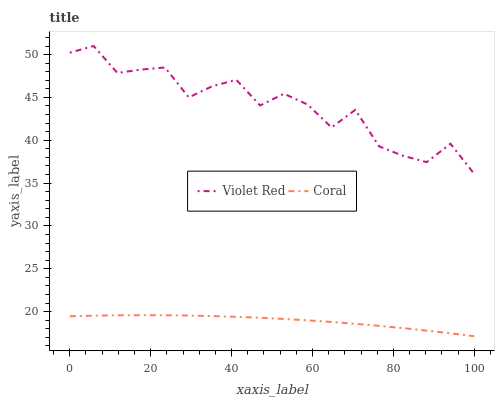Does Coral have the minimum area under the curve?
Answer yes or no. Yes. Does Violet Red have the maximum area under the curve?
Answer yes or no. Yes. Does Coral have the maximum area under the curve?
Answer yes or no. No. Is Coral the smoothest?
Answer yes or no. Yes. Is Violet Red the roughest?
Answer yes or no. Yes. Is Coral the roughest?
Answer yes or no. No. Does Coral have the lowest value?
Answer yes or no. Yes. Does Violet Red have the highest value?
Answer yes or no. Yes. Does Coral have the highest value?
Answer yes or no. No. Is Coral less than Violet Red?
Answer yes or no. Yes. Is Violet Red greater than Coral?
Answer yes or no. Yes. Does Coral intersect Violet Red?
Answer yes or no. No. 